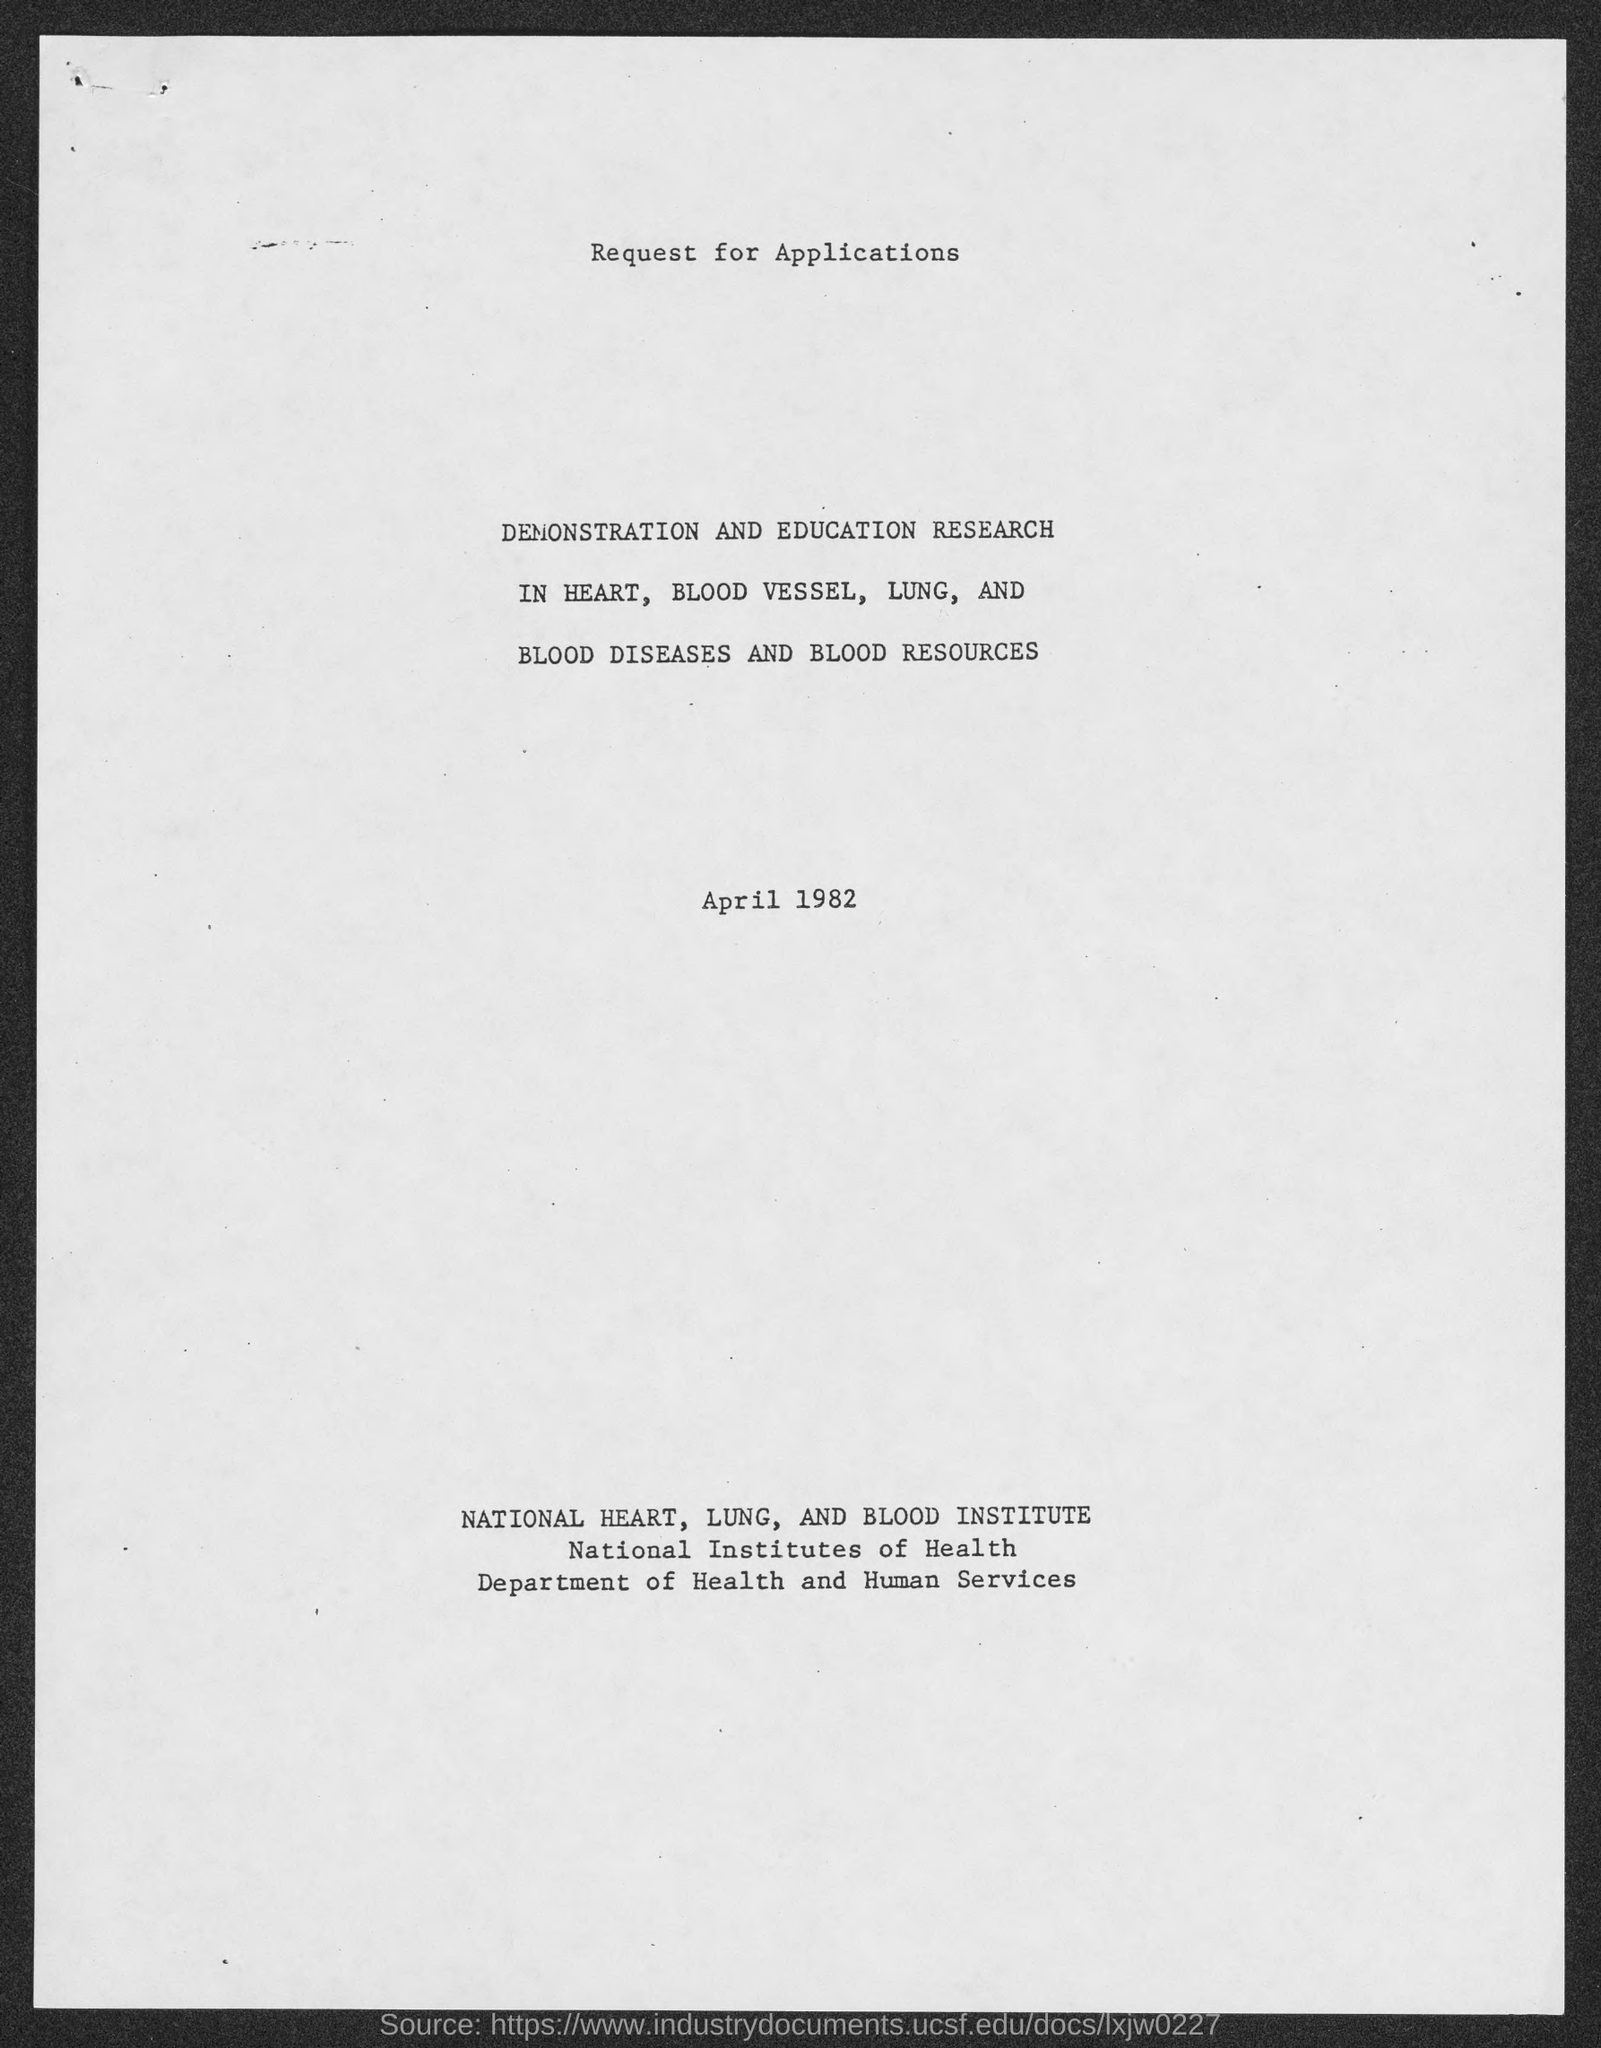Give some essential details in this illustration. The document is dated April 1982. The Department of Health and Human Services is mentioned. 